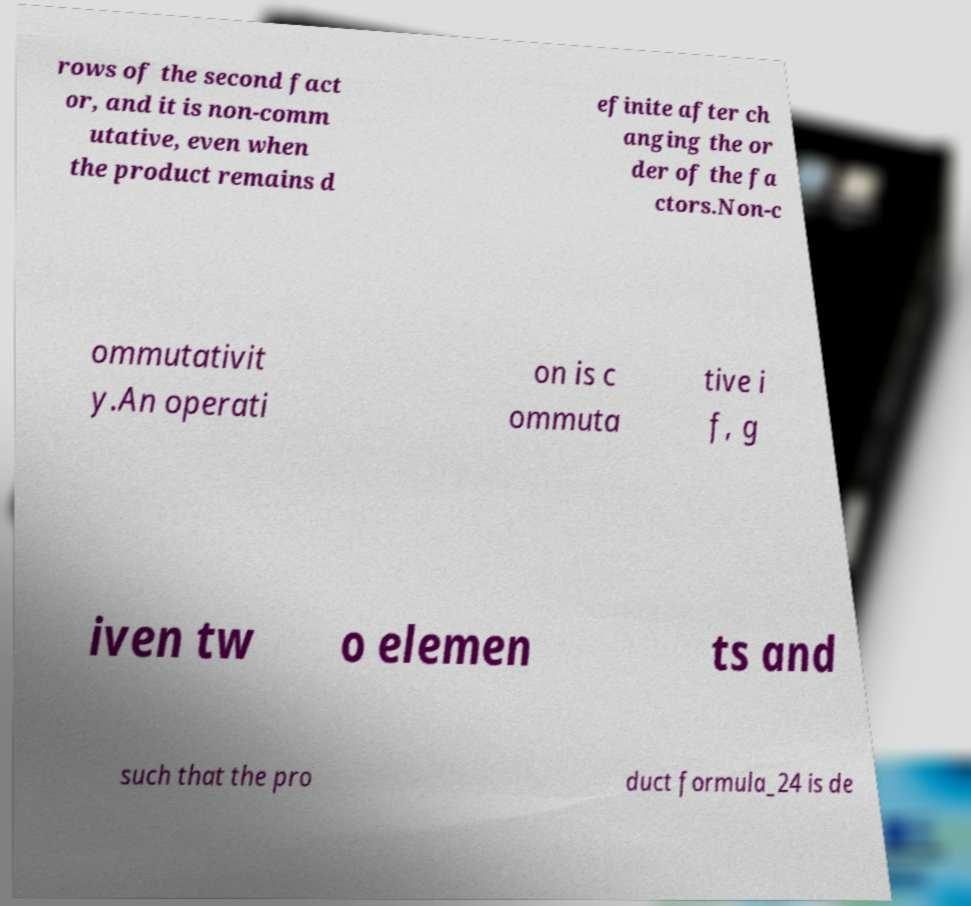Could you extract and type out the text from this image? rows of the second fact or, and it is non-comm utative, even when the product remains d efinite after ch anging the or der of the fa ctors.Non-c ommutativit y.An operati on is c ommuta tive i f, g iven tw o elemen ts and such that the pro duct formula_24 is de 